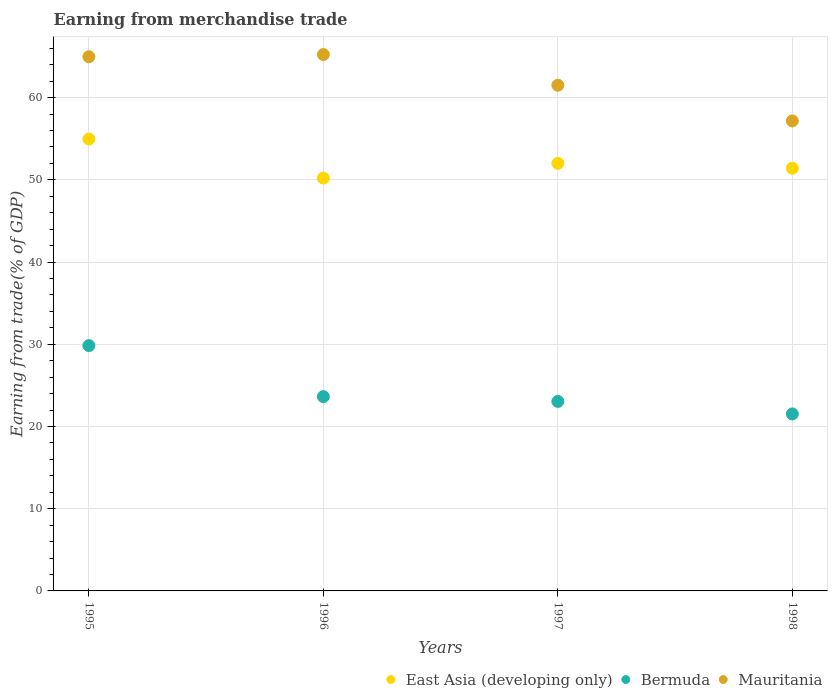How many different coloured dotlines are there?
Provide a short and direct response. 3. Is the number of dotlines equal to the number of legend labels?
Offer a very short reply. Yes. What is the earnings from trade in East Asia (developing only) in 1995?
Ensure brevity in your answer.  54.96. Across all years, what is the maximum earnings from trade in East Asia (developing only)?
Offer a terse response. 54.96. Across all years, what is the minimum earnings from trade in Bermuda?
Your answer should be very brief. 21.53. In which year was the earnings from trade in Bermuda maximum?
Offer a terse response. 1995. In which year was the earnings from trade in Mauritania minimum?
Provide a succinct answer. 1998. What is the total earnings from trade in East Asia (developing only) in the graph?
Your answer should be very brief. 208.6. What is the difference between the earnings from trade in East Asia (developing only) in 1997 and that in 1998?
Make the answer very short. 0.59. What is the difference between the earnings from trade in Mauritania in 1997 and the earnings from trade in East Asia (developing only) in 1996?
Offer a very short reply. 11.29. What is the average earnings from trade in Bermuda per year?
Make the answer very short. 24.51. In the year 1997, what is the difference between the earnings from trade in East Asia (developing only) and earnings from trade in Bermuda?
Keep it short and to the point. 28.96. What is the ratio of the earnings from trade in East Asia (developing only) in 1996 to that in 1998?
Ensure brevity in your answer.  0.98. What is the difference between the highest and the second highest earnings from trade in Mauritania?
Your response must be concise. 0.27. What is the difference between the highest and the lowest earnings from trade in East Asia (developing only)?
Your answer should be very brief. 4.75. In how many years, is the earnings from trade in Mauritania greater than the average earnings from trade in Mauritania taken over all years?
Your answer should be compact. 2. Is it the case that in every year, the sum of the earnings from trade in Bermuda and earnings from trade in Mauritania  is greater than the earnings from trade in East Asia (developing only)?
Ensure brevity in your answer.  Yes. Does the earnings from trade in East Asia (developing only) monotonically increase over the years?
Give a very brief answer. No. Is the earnings from trade in Mauritania strictly greater than the earnings from trade in Bermuda over the years?
Keep it short and to the point. Yes. Is the earnings from trade in East Asia (developing only) strictly less than the earnings from trade in Mauritania over the years?
Make the answer very short. Yes. Are the values on the major ticks of Y-axis written in scientific E-notation?
Your answer should be compact. No. Where does the legend appear in the graph?
Your response must be concise. Bottom right. How many legend labels are there?
Offer a terse response. 3. What is the title of the graph?
Make the answer very short. Earning from merchandise trade. Does "Montenegro" appear as one of the legend labels in the graph?
Give a very brief answer. No. What is the label or title of the X-axis?
Your answer should be very brief. Years. What is the label or title of the Y-axis?
Provide a short and direct response. Earning from trade(% of GDP). What is the Earning from trade(% of GDP) of East Asia (developing only) in 1995?
Make the answer very short. 54.96. What is the Earning from trade(% of GDP) of Bermuda in 1995?
Ensure brevity in your answer.  29.84. What is the Earning from trade(% of GDP) in Mauritania in 1995?
Give a very brief answer. 64.97. What is the Earning from trade(% of GDP) in East Asia (developing only) in 1996?
Your response must be concise. 50.21. What is the Earning from trade(% of GDP) in Bermuda in 1996?
Offer a very short reply. 23.63. What is the Earning from trade(% of GDP) in Mauritania in 1996?
Provide a short and direct response. 65.24. What is the Earning from trade(% of GDP) of East Asia (developing only) in 1997?
Keep it short and to the point. 52.01. What is the Earning from trade(% of GDP) in Bermuda in 1997?
Ensure brevity in your answer.  23.05. What is the Earning from trade(% of GDP) in Mauritania in 1997?
Your answer should be very brief. 61.51. What is the Earning from trade(% of GDP) in East Asia (developing only) in 1998?
Ensure brevity in your answer.  51.41. What is the Earning from trade(% of GDP) in Bermuda in 1998?
Provide a succinct answer. 21.53. What is the Earning from trade(% of GDP) in Mauritania in 1998?
Your answer should be compact. 57.17. Across all years, what is the maximum Earning from trade(% of GDP) of East Asia (developing only)?
Your answer should be very brief. 54.96. Across all years, what is the maximum Earning from trade(% of GDP) of Bermuda?
Offer a very short reply. 29.84. Across all years, what is the maximum Earning from trade(% of GDP) of Mauritania?
Provide a short and direct response. 65.24. Across all years, what is the minimum Earning from trade(% of GDP) of East Asia (developing only)?
Your answer should be compact. 50.21. Across all years, what is the minimum Earning from trade(% of GDP) in Bermuda?
Provide a short and direct response. 21.53. Across all years, what is the minimum Earning from trade(% of GDP) in Mauritania?
Provide a succinct answer. 57.17. What is the total Earning from trade(% of GDP) in East Asia (developing only) in the graph?
Ensure brevity in your answer.  208.6. What is the total Earning from trade(% of GDP) in Bermuda in the graph?
Your answer should be compact. 98.05. What is the total Earning from trade(% of GDP) of Mauritania in the graph?
Provide a succinct answer. 248.89. What is the difference between the Earning from trade(% of GDP) in East Asia (developing only) in 1995 and that in 1996?
Your response must be concise. 4.75. What is the difference between the Earning from trade(% of GDP) in Bermuda in 1995 and that in 1996?
Give a very brief answer. 6.21. What is the difference between the Earning from trade(% of GDP) in Mauritania in 1995 and that in 1996?
Your answer should be compact. -0.27. What is the difference between the Earning from trade(% of GDP) in East Asia (developing only) in 1995 and that in 1997?
Provide a succinct answer. 2.95. What is the difference between the Earning from trade(% of GDP) in Bermuda in 1995 and that in 1997?
Give a very brief answer. 6.79. What is the difference between the Earning from trade(% of GDP) of Mauritania in 1995 and that in 1997?
Keep it short and to the point. 3.47. What is the difference between the Earning from trade(% of GDP) of East Asia (developing only) in 1995 and that in 1998?
Offer a very short reply. 3.55. What is the difference between the Earning from trade(% of GDP) of Bermuda in 1995 and that in 1998?
Make the answer very short. 8.31. What is the difference between the Earning from trade(% of GDP) of Mauritania in 1995 and that in 1998?
Make the answer very short. 7.81. What is the difference between the Earning from trade(% of GDP) of East Asia (developing only) in 1996 and that in 1997?
Your answer should be very brief. -1.79. What is the difference between the Earning from trade(% of GDP) of Bermuda in 1996 and that in 1997?
Keep it short and to the point. 0.58. What is the difference between the Earning from trade(% of GDP) in Mauritania in 1996 and that in 1997?
Provide a succinct answer. 3.73. What is the difference between the Earning from trade(% of GDP) in East Asia (developing only) in 1996 and that in 1998?
Your answer should be compact. -1.2. What is the difference between the Earning from trade(% of GDP) in Bermuda in 1996 and that in 1998?
Make the answer very short. 2.1. What is the difference between the Earning from trade(% of GDP) of Mauritania in 1996 and that in 1998?
Offer a terse response. 8.07. What is the difference between the Earning from trade(% of GDP) in East Asia (developing only) in 1997 and that in 1998?
Ensure brevity in your answer.  0.59. What is the difference between the Earning from trade(% of GDP) of Bermuda in 1997 and that in 1998?
Ensure brevity in your answer.  1.52. What is the difference between the Earning from trade(% of GDP) of Mauritania in 1997 and that in 1998?
Your response must be concise. 4.34. What is the difference between the Earning from trade(% of GDP) in East Asia (developing only) in 1995 and the Earning from trade(% of GDP) in Bermuda in 1996?
Make the answer very short. 31.33. What is the difference between the Earning from trade(% of GDP) of East Asia (developing only) in 1995 and the Earning from trade(% of GDP) of Mauritania in 1996?
Your response must be concise. -10.28. What is the difference between the Earning from trade(% of GDP) of Bermuda in 1995 and the Earning from trade(% of GDP) of Mauritania in 1996?
Ensure brevity in your answer.  -35.4. What is the difference between the Earning from trade(% of GDP) in East Asia (developing only) in 1995 and the Earning from trade(% of GDP) in Bermuda in 1997?
Give a very brief answer. 31.91. What is the difference between the Earning from trade(% of GDP) of East Asia (developing only) in 1995 and the Earning from trade(% of GDP) of Mauritania in 1997?
Your response must be concise. -6.54. What is the difference between the Earning from trade(% of GDP) of Bermuda in 1995 and the Earning from trade(% of GDP) of Mauritania in 1997?
Your response must be concise. -31.66. What is the difference between the Earning from trade(% of GDP) in East Asia (developing only) in 1995 and the Earning from trade(% of GDP) in Bermuda in 1998?
Ensure brevity in your answer.  33.43. What is the difference between the Earning from trade(% of GDP) of East Asia (developing only) in 1995 and the Earning from trade(% of GDP) of Mauritania in 1998?
Make the answer very short. -2.21. What is the difference between the Earning from trade(% of GDP) in Bermuda in 1995 and the Earning from trade(% of GDP) in Mauritania in 1998?
Your response must be concise. -27.33. What is the difference between the Earning from trade(% of GDP) of East Asia (developing only) in 1996 and the Earning from trade(% of GDP) of Bermuda in 1997?
Your response must be concise. 27.16. What is the difference between the Earning from trade(% of GDP) of East Asia (developing only) in 1996 and the Earning from trade(% of GDP) of Mauritania in 1997?
Provide a short and direct response. -11.29. What is the difference between the Earning from trade(% of GDP) in Bermuda in 1996 and the Earning from trade(% of GDP) in Mauritania in 1997?
Offer a terse response. -37.87. What is the difference between the Earning from trade(% of GDP) of East Asia (developing only) in 1996 and the Earning from trade(% of GDP) of Bermuda in 1998?
Make the answer very short. 28.69. What is the difference between the Earning from trade(% of GDP) of East Asia (developing only) in 1996 and the Earning from trade(% of GDP) of Mauritania in 1998?
Provide a succinct answer. -6.95. What is the difference between the Earning from trade(% of GDP) of Bermuda in 1996 and the Earning from trade(% of GDP) of Mauritania in 1998?
Make the answer very short. -33.54. What is the difference between the Earning from trade(% of GDP) in East Asia (developing only) in 1997 and the Earning from trade(% of GDP) in Bermuda in 1998?
Offer a terse response. 30.48. What is the difference between the Earning from trade(% of GDP) in East Asia (developing only) in 1997 and the Earning from trade(% of GDP) in Mauritania in 1998?
Provide a short and direct response. -5.16. What is the difference between the Earning from trade(% of GDP) in Bermuda in 1997 and the Earning from trade(% of GDP) in Mauritania in 1998?
Offer a terse response. -34.12. What is the average Earning from trade(% of GDP) in East Asia (developing only) per year?
Your answer should be compact. 52.15. What is the average Earning from trade(% of GDP) in Bermuda per year?
Make the answer very short. 24.51. What is the average Earning from trade(% of GDP) in Mauritania per year?
Your response must be concise. 62.22. In the year 1995, what is the difference between the Earning from trade(% of GDP) of East Asia (developing only) and Earning from trade(% of GDP) of Bermuda?
Offer a terse response. 25.12. In the year 1995, what is the difference between the Earning from trade(% of GDP) of East Asia (developing only) and Earning from trade(% of GDP) of Mauritania?
Provide a short and direct response. -10.01. In the year 1995, what is the difference between the Earning from trade(% of GDP) of Bermuda and Earning from trade(% of GDP) of Mauritania?
Provide a short and direct response. -35.13. In the year 1996, what is the difference between the Earning from trade(% of GDP) in East Asia (developing only) and Earning from trade(% of GDP) in Bermuda?
Offer a terse response. 26.58. In the year 1996, what is the difference between the Earning from trade(% of GDP) of East Asia (developing only) and Earning from trade(% of GDP) of Mauritania?
Make the answer very short. -15.03. In the year 1996, what is the difference between the Earning from trade(% of GDP) of Bermuda and Earning from trade(% of GDP) of Mauritania?
Give a very brief answer. -41.61. In the year 1997, what is the difference between the Earning from trade(% of GDP) of East Asia (developing only) and Earning from trade(% of GDP) of Bermuda?
Keep it short and to the point. 28.96. In the year 1997, what is the difference between the Earning from trade(% of GDP) of East Asia (developing only) and Earning from trade(% of GDP) of Mauritania?
Offer a terse response. -9.5. In the year 1997, what is the difference between the Earning from trade(% of GDP) in Bermuda and Earning from trade(% of GDP) in Mauritania?
Make the answer very short. -38.46. In the year 1998, what is the difference between the Earning from trade(% of GDP) in East Asia (developing only) and Earning from trade(% of GDP) in Bermuda?
Provide a succinct answer. 29.89. In the year 1998, what is the difference between the Earning from trade(% of GDP) in East Asia (developing only) and Earning from trade(% of GDP) in Mauritania?
Provide a succinct answer. -5.75. In the year 1998, what is the difference between the Earning from trade(% of GDP) in Bermuda and Earning from trade(% of GDP) in Mauritania?
Give a very brief answer. -35.64. What is the ratio of the Earning from trade(% of GDP) of East Asia (developing only) in 1995 to that in 1996?
Offer a terse response. 1.09. What is the ratio of the Earning from trade(% of GDP) of Bermuda in 1995 to that in 1996?
Give a very brief answer. 1.26. What is the ratio of the Earning from trade(% of GDP) in East Asia (developing only) in 1995 to that in 1997?
Provide a short and direct response. 1.06. What is the ratio of the Earning from trade(% of GDP) of Bermuda in 1995 to that in 1997?
Offer a very short reply. 1.29. What is the ratio of the Earning from trade(% of GDP) in Mauritania in 1995 to that in 1997?
Provide a succinct answer. 1.06. What is the ratio of the Earning from trade(% of GDP) in East Asia (developing only) in 1995 to that in 1998?
Your answer should be compact. 1.07. What is the ratio of the Earning from trade(% of GDP) in Bermuda in 1995 to that in 1998?
Provide a succinct answer. 1.39. What is the ratio of the Earning from trade(% of GDP) of Mauritania in 1995 to that in 1998?
Give a very brief answer. 1.14. What is the ratio of the Earning from trade(% of GDP) in East Asia (developing only) in 1996 to that in 1997?
Offer a terse response. 0.97. What is the ratio of the Earning from trade(% of GDP) in Bermuda in 1996 to that in 1997?
Provide a succinct answer. 1.03. What is the ratio of the Earning from trade(% of GDP) in Mauritania in 1996 to that in 1997?
Offer a terse response. 1.06. What is the ratio of the Earning from trade(% of GDP) of East Asia (developing only) in 1996 to that in 1998?
Offer a terse response. 0.98. What is the ratio of the Earning from trade(% of GDP) of Bermuda in 1996 to that in 1998?
Keep it short and to the point. 1.1. What is the ratio of the Earning from trade(% of GDP) in Mauritania in 1996 to that in 1998?
Give a very brief answer. 1.14. What is the ratio of the Earning from trade(% of GDP) in East Asia (developing only) in 1997 to that in 1998?
Your answer should be compact. 1.01. What is the ratio of the Earning from trade(% of GDP) of Bermuda in 1997 to that in 1998?
Your response must be concise. 1.07. What is the ratio of the Earning from trade(% of GDP) of Mauritania in 1997 to that in 1998?
Provide a short and direct response. 1.08. What is the difference between the highest and the second highest Earning from trade(% of GDP) in East Asia (developing only)?
Keep it short and to the point. 2.95. What is the difference between the highest and the second highest Earning from trade(% of GDP) in Bermuda?
Offer a terse response. 6.21. What is the difference between the highest and the second highest Earning from trade(% of GDP) of Mauritania?
Offer a terse response. 0.27. What is the difference between the highest and the lowest Earning from trade(% of GDP) in East Asia (developing only)?
Provide a short and direct response. 4.75. What is the difference between the highest and the lowest Earning from trade(% of GDP) in Bermuda?
Your answer should be very brief. 8.31. What is the difference between the highest and the lowest Earning from trade(% of GDP) in Mauritania?
Provide a short and direct response. 8.07. 